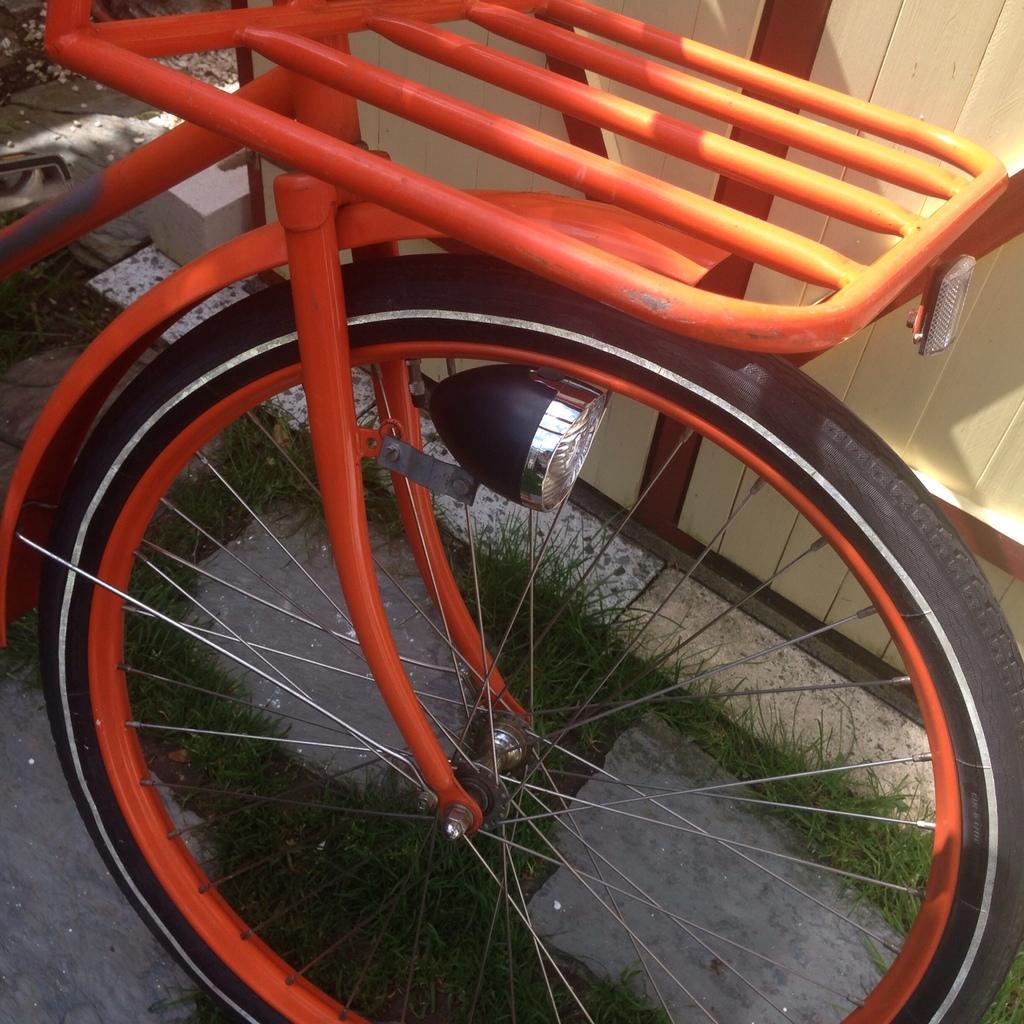Can you describe this image briefly? In this image we can see a vehicle. In the background of the image there are stones, grass, wall and other objects. 